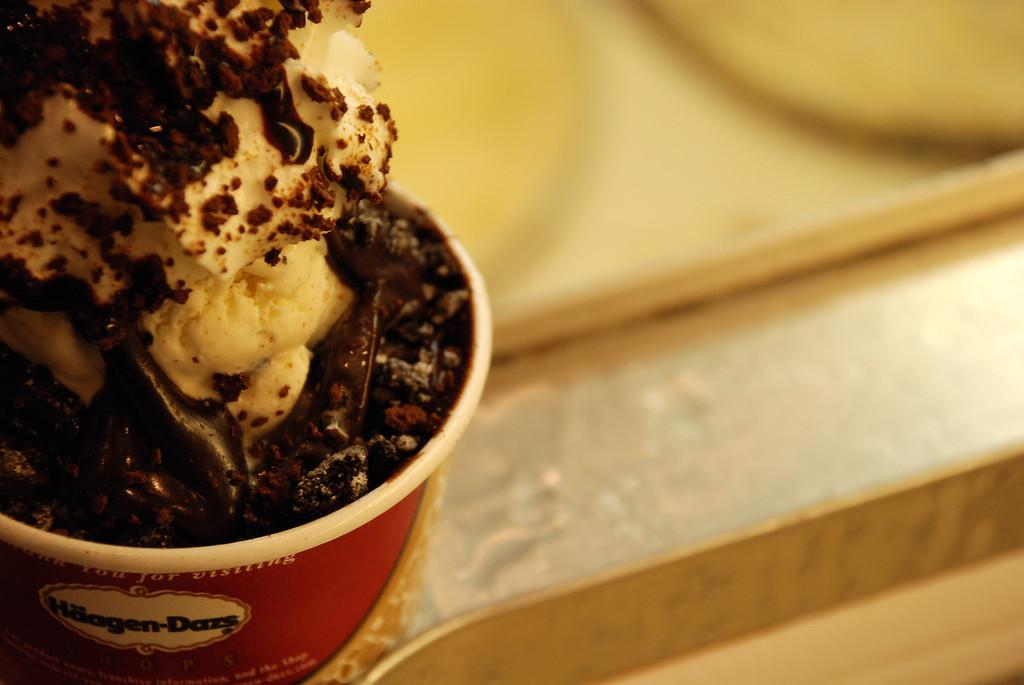What is located on the left side of the image? There is an ice cream on the left side of the image. What objects can be seen in the image besides the ice cream? There are trays in the image. Where is the giraffe standing in the image? There is no giraffe present in the image. What type of structure can be seen in the image? The image does not show any structures; it only contains an ice cream and trays. 